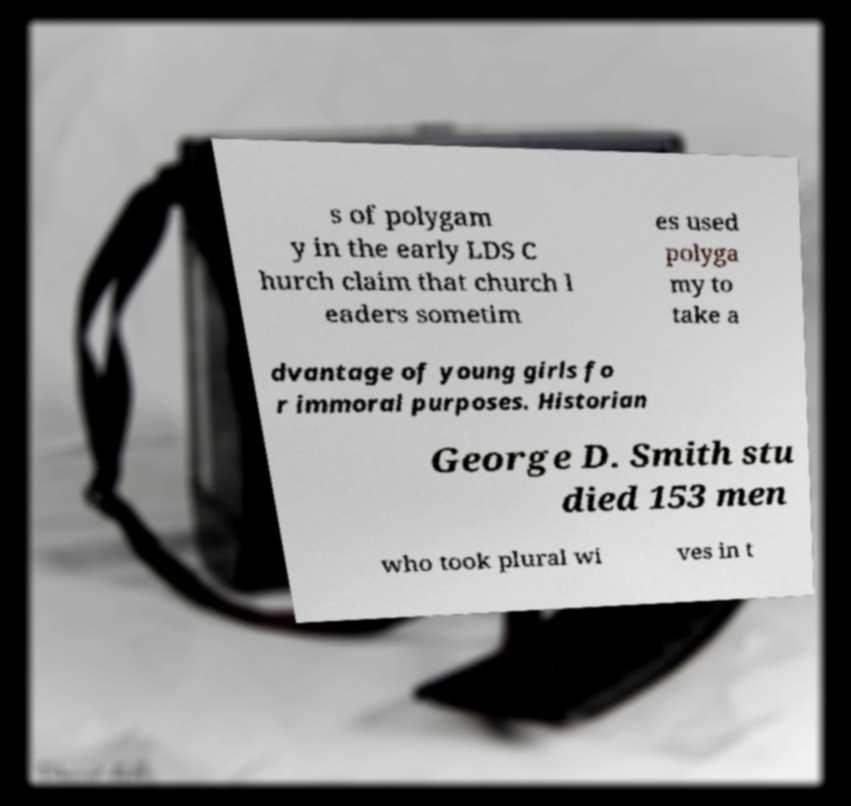For documentation purposes, I need the text within this image transcribed. Could you provide that? s of polygam y in the early LDS C hurch claim that church l eaders sometim es used polyga my to take a dvantage of young girls fo r immoral purposes. Historian George D. Smith stu died 153 men who took plural wi ves in t 